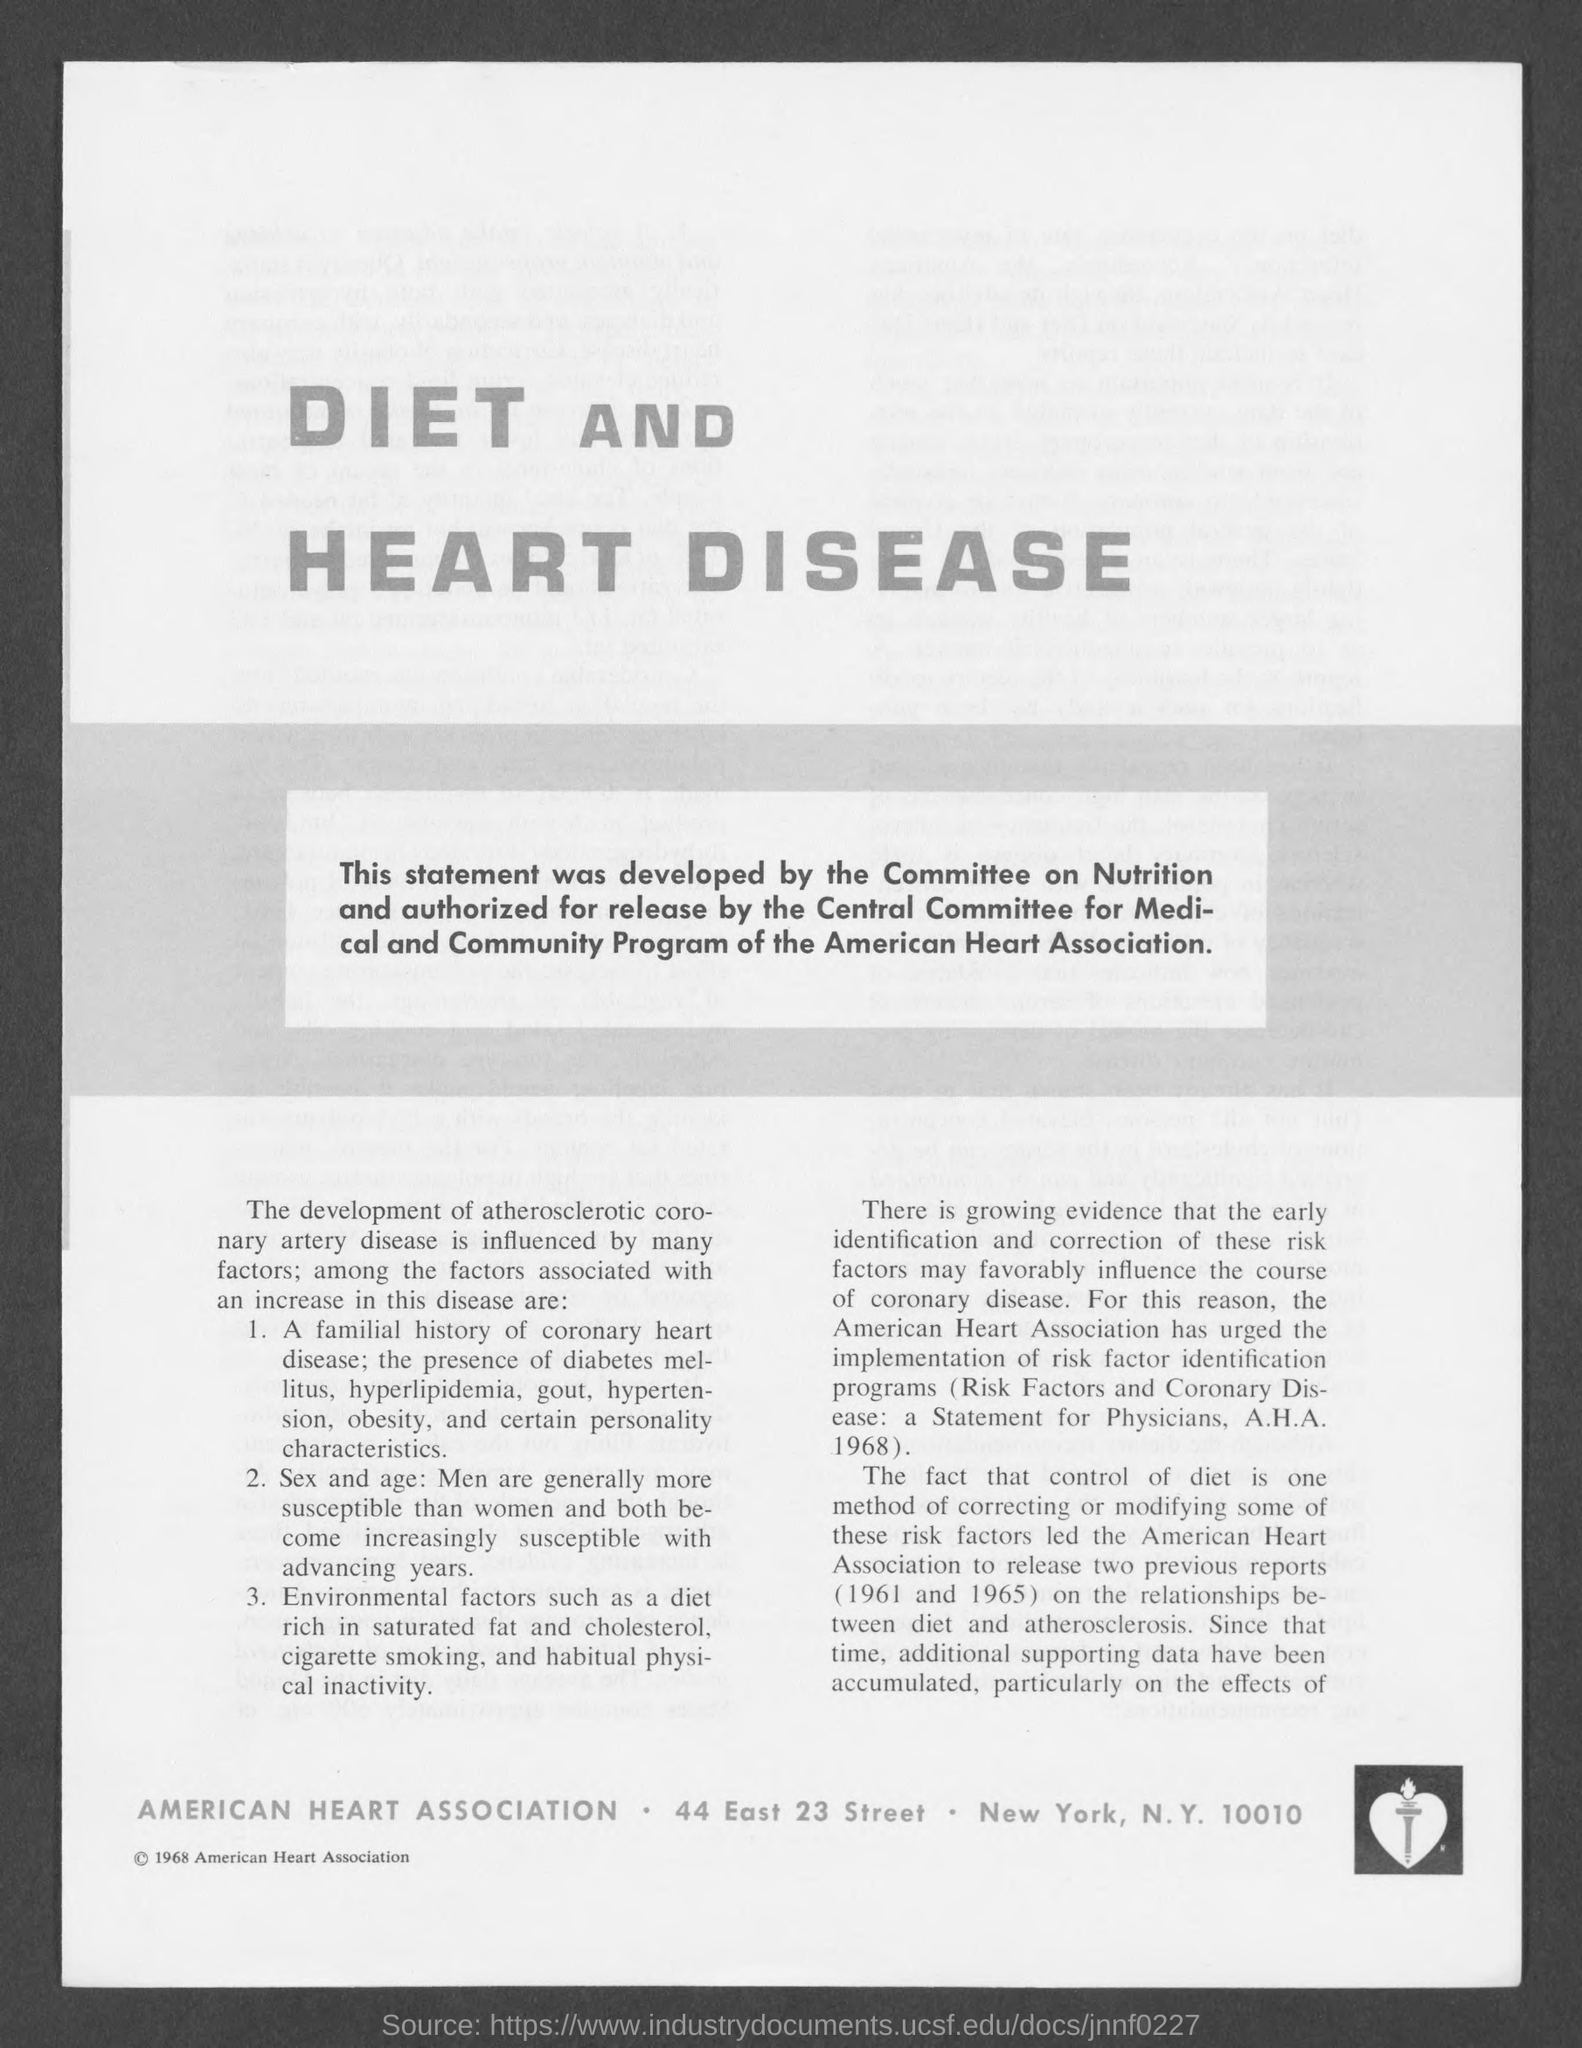Highlight a few significant elements in this photo. The American Heart Association is located in New York City. 